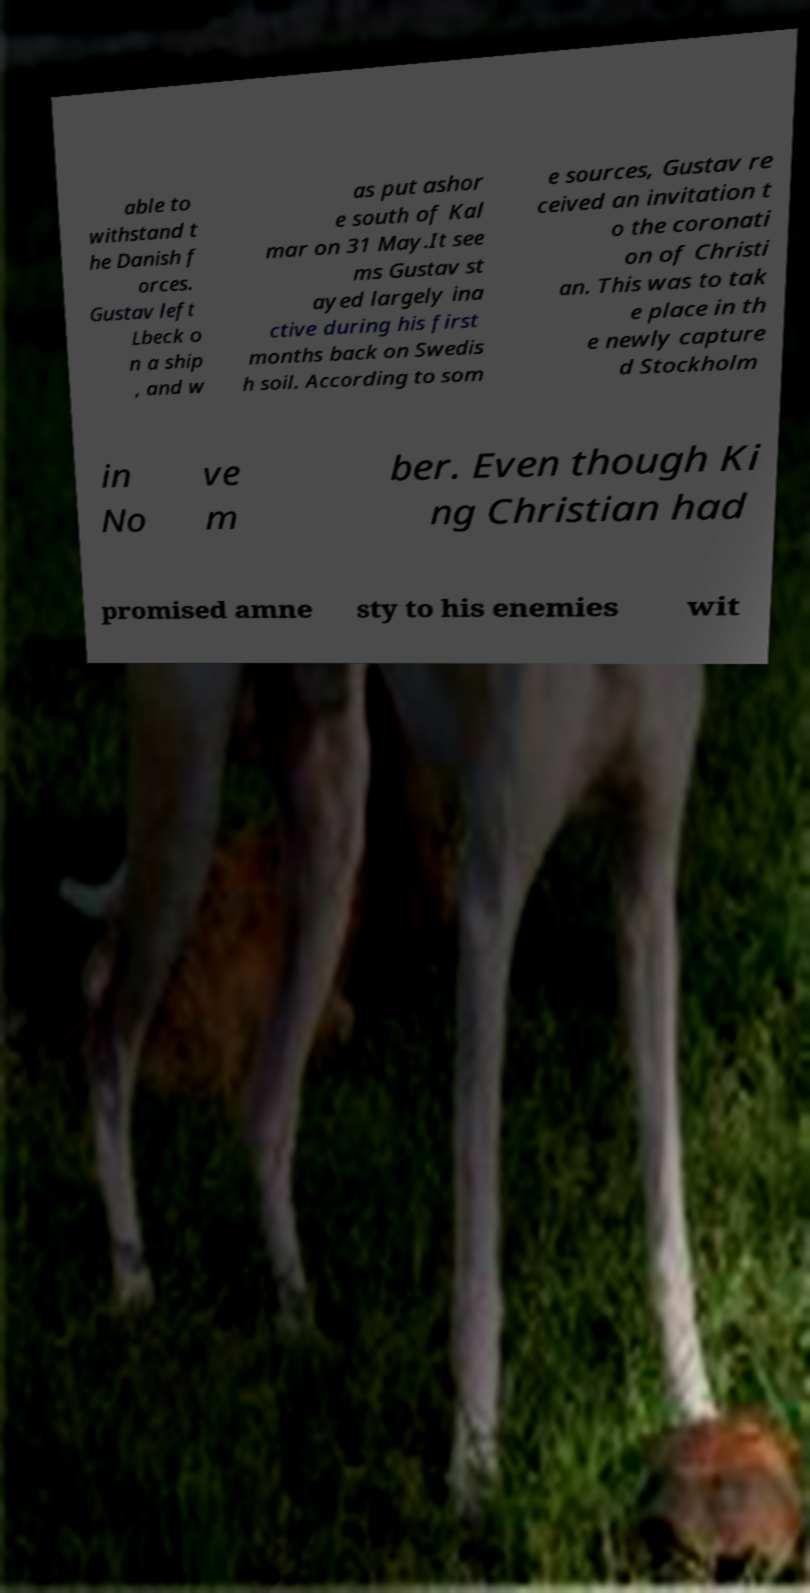There's text embedded in this image that I need extracted. Can you transcribe it verbatim? able to withstand t he Danish f orces. Gustav left Lbeck o n a ship , and w as put ashor e south of Kal mar on 31 May.It see ms Gustav st ayed largely ina ctive during his first months back on Swedis h soil. According to som e sources, Gustav re ceived an invitation t o the coronati on of Christi an. This was to tak e place in th e newly capture d Stockholm in No ve m ber. Even though Ki ng Christian had promised amne sty to his enemies wit 